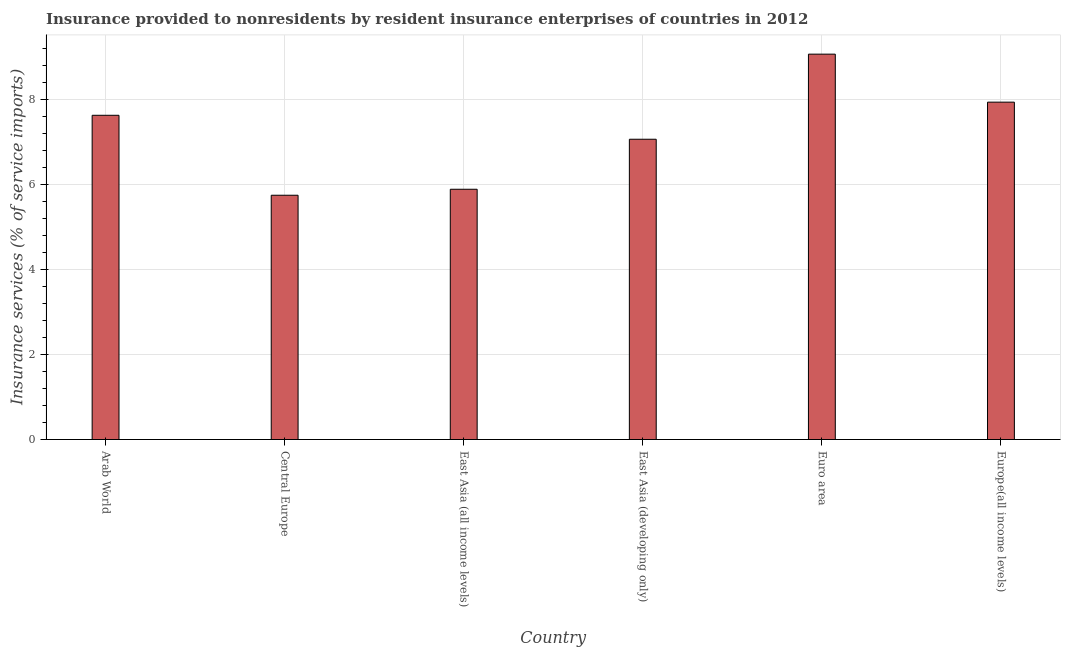Does the graph contain any zero values?
Provide a succinct answer. No. Does the graph contain grids?
Provide a short and direct response. Yes. What is the title of the graph?
Keep it short and to the point. Insurance provided to nonresidents by resident insurance enterprises of countries in 2012. What is the label or title of the X-axis?
Keep it short and to the point. Country. What is the label or title of the Y-axis?
Your answer should be very brief. Insurance services (% of service imports). What is the insurance and financial services in Central Europe?
Offer a terse response. 5.74. Across all countries, what is the maximum insurance and financial services?
Ensure brevity in your answer.  9.06. Across all countries, what is the minimum insurance and financial services?
Provide a short and direct response. 5.74. In which country was the insurance and financial services minimum?
Your response must be concise. Central Europe. What is the sum of the insurance and financial services?
Provide a short and direct response. 43.3. What is the difference between the insurance and financial services in East Asia (developing only) and Europe(all income levels)?
Your answer should be compact. -0.87. What is the average insurance and financial services per country?
Your response must be concise. 7.22. What is the median insurance and financial services?
Give a very brief answer. 7.34. In how many countries, is the insurance and financial services greater than 8.4 %?
Ensure brevity in your answer.  1. What is the ratio of the insurance and financial services in Central Europe to that in East Asia (developing only)?
Keep it short and to the point. 0.81. Is the insurance and financial services in Central Europe less than that in Europe(all income levels)?
Provide a succinct answer. Yes. What is the difference between the highest and the second highest insurance and financial services?
Your response must be concise. 1.13. What is the difference between the highest and the lowest insurance and financial services?
Ensure brevity in your answer.  3.32. What is the difference between two consecutive major ticks on the Y-axis?
Your response must be concise. 2. What is the Insurance services (% of service imports) in Arab World?
Ensure brevity in your answer.  7.62. What is the Insurance services (% of service imports) of Central Europe?
Make the answer very short. 5.74. What is the Insurance services (% of service imports) of East Asia (all income levels)?
Give a very brief answer. 5.88. What is the Insurance services (% of service imports) of East Asia (developing only)?
Your response must be concise. 7.06. What is the Insurance services (% of service imports) of Euro area?
Ensure brevity in your answer.  9.06. What is the Insurance services (% of service imports) in Europe(all income levels)?
Ensure brevity in your answer.  7.93. What is the difference between the Insurance services (% of service imports) in Arab World and Central Europe?
Ensure brevity in your answer.  1.88. What is the difference between the Insurance services (% of service imports) in Arab World and East Asia (all income levels)?
Ensure brevity in your answer.  1.74. What is the difference between the Insurance services (% of service imports) in Arab World and East Asia (developing only)?
Keep it short and to the point. 0.56. What is the difference between the Insurance services (% of service imports) in Arab World and Euro area?
Your response must be concise. -1.44. What is the difference between the Insurance services (% of service imports) in Arab World and Europe(all income levels)?
Provide a short and direct response. -0.31. What is the difference between the Insurance services (% of service imports) in Central Europe and East Asia (all income levels)?
Your answer should be very brief. -0.14. What is the difference between the Insurance services (% of service imports) in Central Europe and East Asia (developing only)?
Offer a very short reply. -1.32. What is the difference between the Insurance services (% of service imports) in Central Europe and Euro area?
Ensure brevity in your answer.  -3.32. What is the difference between the Insurance services (% of service imports) in Central Europe and Europe(all income levels)?
Offer a very short reply. -2.19. What is the difference between the Insurance services (% of service imports) in East Asia (all income levels) and East Asia (developing only)?
Offer a terse response. -1.18. What is the difference between the Insurance services (% of service imports) in East Asia (all income levels) and Euro area?
Give a very brief answer. -3.18. What is the difference between the Insurance services (% of service imports) in East Asia (all income levels) and Europe(all income levels)?
Your answer should be compact. -2.05. What is the difference between the Insurance services (% of service imports) in East Asia (developing only) and Euro area?
Offer a terse response. -2. What is the difference between the Insurance services (% of service imports) in East Asia (developing only) and Europe(all income levels)?
Provide a short and direct response. -0.87. What is the difference between the Insurance services (% of service imports) in Euro area and Europe(all income levels)?
Keep it short and to the point. 1.13. What is the ratio of the Insurance services (% of service imports) in Arab World to that in Central Europe?
Keep it short and to the point. 1.33. What is the ratio of the Insurance services (% of service imports) in Arab World to that in East Asia (all income levels)?
Your answer should be compact. 1.3. What is the ratio of the Insurance services (% of service imports) in Arab World to that in East Asia (developing only)?
Offer a terse response. 1.08. What is the ratio of the Insurance services (% of service imports) in Arab World to that in Euro area?
Offer a terse response. 0.84. What is the ratio of the Insurance services (% of service imports) in Arab World to that in Europe(all income levels)?
Your response must be concise. 0.96. What is the ratio of the Insurance services (% of service imports) in Central Europe to that in East Asia (all income levels)?
Your response must be concise. 0.98. What is the ratio of the Insurance services (% of service imports) in Central Europe to that in East Asia (developing only)?
Make the answer very short. 0.81. What is the ratio of the Insurance services (% of service imports) in Central Europe to that in Euro area?
Your answer should be very brief. 0.63. What is the ratio of the Insurance services (% of service imports) in Central Europe to that in Europe(all income levels)?
Offer a terse response. 0.72. What is the ratio of the Insurance services (% of service imports) in East Asia (all income levels) to that in East Asia (developing only)?
Provide a short and direct response. 0.83. What is the ratio of the Insurance services (% of service imports) in East Asia (all income levels) to that in Euro area?
Offer a very short reply. 0.65. What is the ratio of the Insurance services (% of service imports) in East Asia (all income levels) to that in Europe(all income levels)?
Ensure brevity in your answer.  0.74. What is the ratio of the Insurance services (% of service imports) in East Asia (developing only) to that in Euro area?
Make the answer very short. 0.78. What is the ratio of the Insurance services (% of service imports) in East Asia (developing only) to that in Europe(all income levels)?
Provide a short and direct response. 0.89. What is the ratio of the Insurance services (% of service imports) in Euro area to that in Europe(all income levels)?
Your answer should be compact. 1.14. 